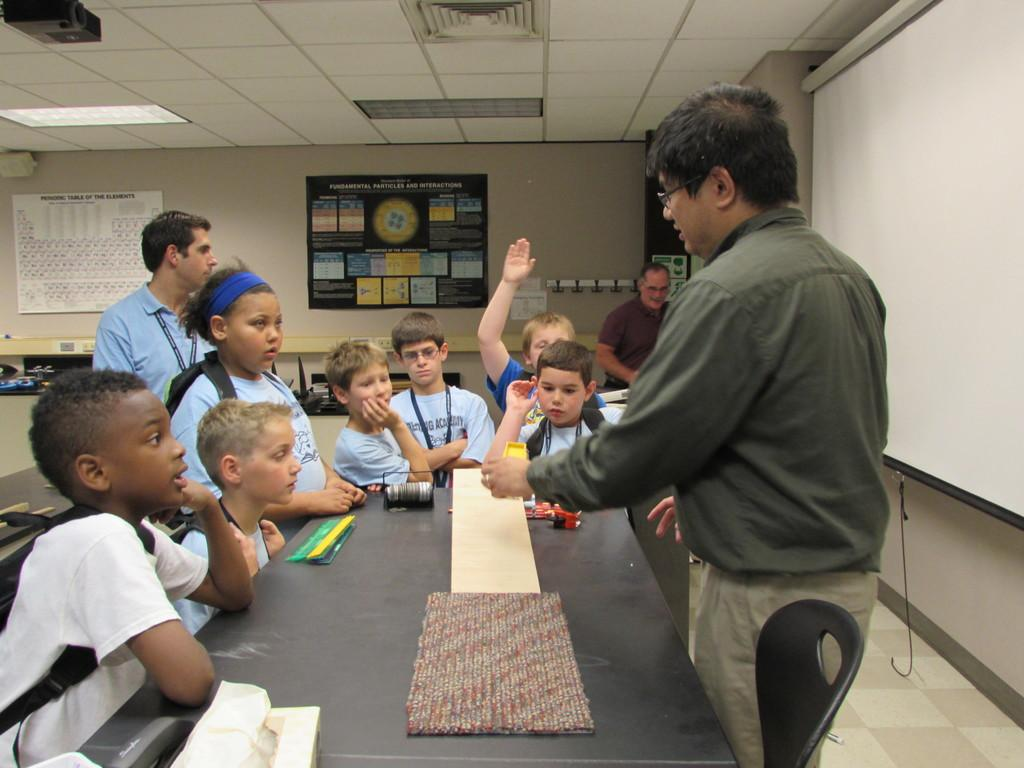How many people are in the image? There are people in the image, but the exact number is not specified. What type of surface is visible in the image? There is a floor in the image. What type of furniture is present in the image? There is a table and a chair in the image. What type of electronic device is in the image? There is a screen in the image. What other objects can be seen in the image? There are other objects in the image, but their specific nature is not mentioned. What can be seen in the background of the image? There is a wall, a ceiling, a light, boards, and posters in the background of the image. What type of bells can be heard ringing in the image? There are no bells or sounds mentioned in the image, so it is not possible to determine if any bells are ringing. What type of fire is visible in the image? There is no fire present in the image. 